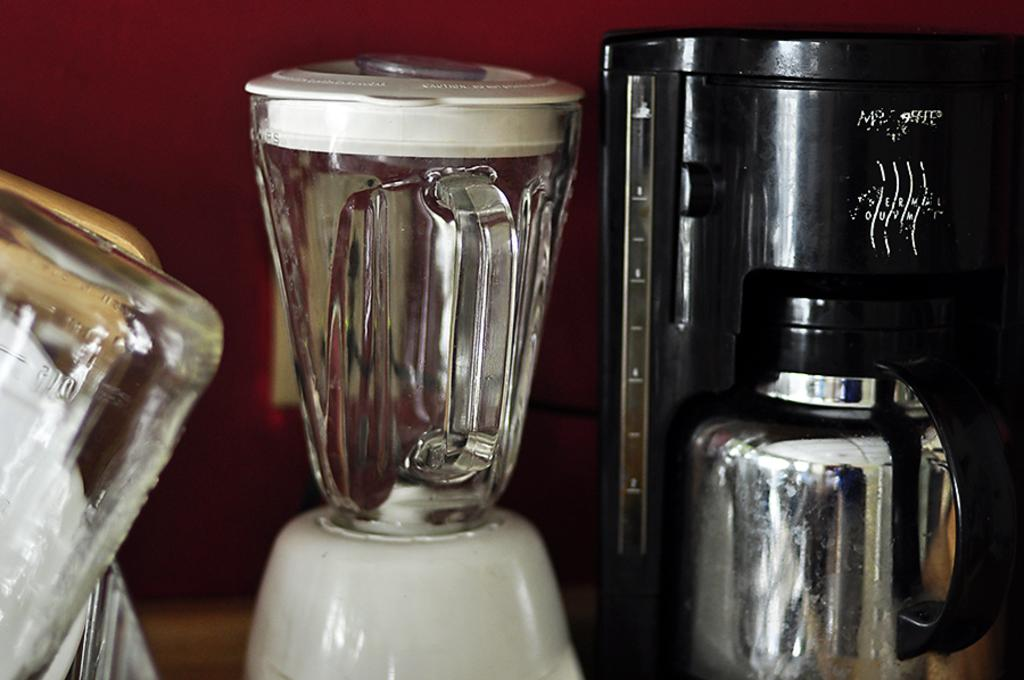What objects are located in the center of the image? There are jars, a grinder, a flask, and a container in the center of the image. What type of container is present in the image? There is a container in the center of the image. What can be seen in the background of the image? There is a wall in the background of the image. What type of furniture is being taught in the image? There is no furniture or teaching depicted in the image; it features jars, a grinder, a flask, and a container in the center, with a wall in the background. How many grapes are visible in the image? There are no grapes present in the image. 